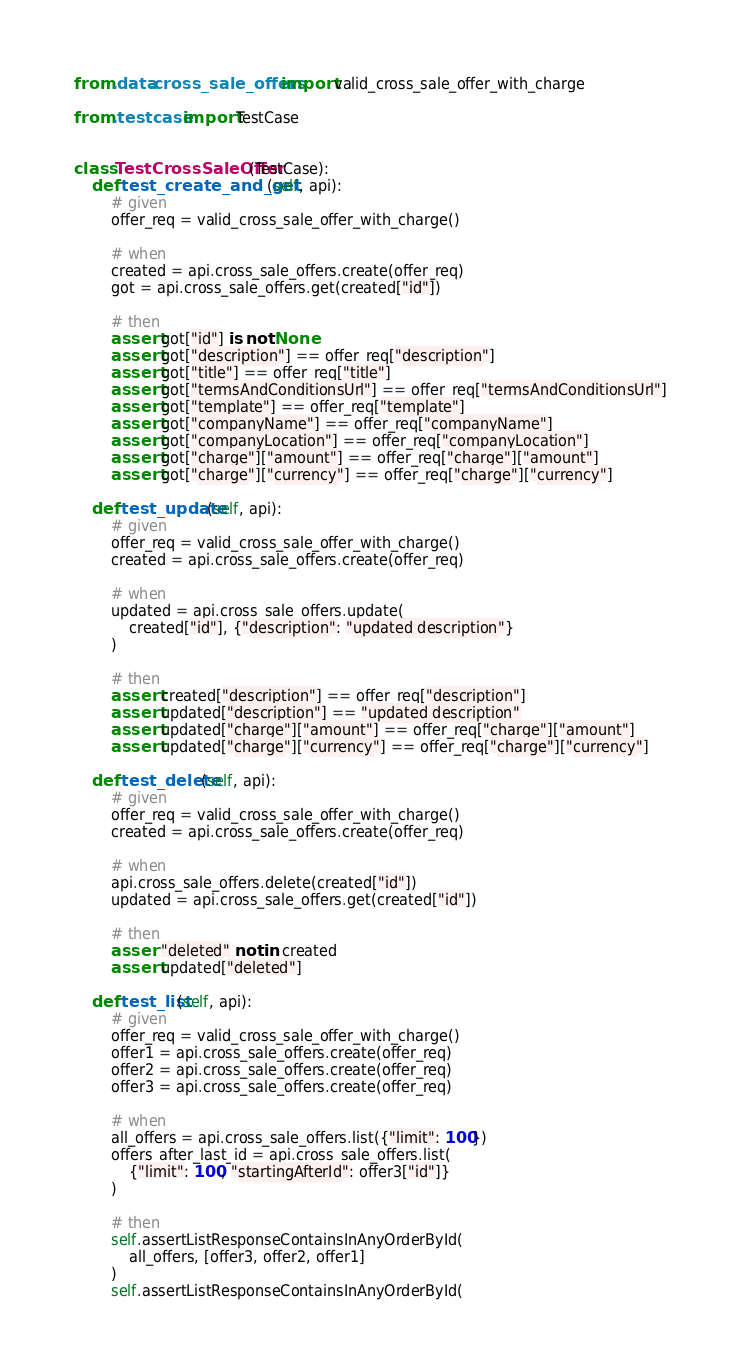<code> <loc_0><loc_0><loc_500><loc_500><_Python_>from .data.cross_sale_offers import valid_cross_sale_offer_with_charge

from .testcase import TestCase


class TestCrossSaleOffer(TestCase):
    def test_create_and_get(self, api):
        # given
        offer_req = valid_cross_sale_offer_with_charge()

        # when
        created = api.cross_sale_offers.create(offer_req)
        got = api.cross_sale_offers.get(created["id"])

        # then
        assert got["id"] is not None
        assert got["description"] == offer_req["description"]
        assert got["title"] == offer_req["title"]
        assert got["termsAndConditionsUrl"] == offer_req["termsAndConditionsUrl"]
        assert got["template"] == offer_req["template"]
        assert got["companyName"] == offer_req["companyName"]
        assert got["companyLocation"] == offer_req["companyLocation"]
        assert got["charge"]["amount"] == offer_req["charge"]["amount"]
        assert got["charge"]["currency"] == offer_req["charge"]["currency"]

    def test_update(self, api):
        # given
        offer_req = valid_cross_sale_offer_with_charge()
        created = api.cross_sale_offers.create(offer_req)

        # when
        updated = api.cross_sale_offers.update(
            created["id"], {"description": "updated description"}
        )

        # then
        assert created["description"] == offer_req["description"]
        assert updated["description"] == "updated description"
        assert updated["charge"]["amount"] == offer_req["charge"]["amount"]
        assert updated["charge"]["currency"] == offer_req["charge"]["currency"]

    def test_delete(self, api):
        # given
        offer_req = valid_cross_sale_offer_with_charge()
        created = api.cross_sale_offers.create(offer_req)

        # when
        api.cross_sale_offers.delete(created["id"])
        updated = api.cross_sale_offers.get(created["id"])

        # then
        assert "deleted" not in created
        assert updated["deleted"]

    def test_list(self, api):
        # given
        offer_req = valid_cross_sale_offer_with_charge()
        offer1 = api.cross_sale_offers.create(offer_req)
        offer2 = api.cross_sale_offers.create(offer_req)
        offer3 = api.cross_sale_offers.create(offer_req)

        # when
        all_offers = api.cross_sale_offers.list({"limit": 100})
        offers_after_last_id = api.cross_sale_offers.list(
            {"limit": 100, "startingAfterId": offer3["id"]}
        )

        # then
        self.assertListResponseContainsInAnyOrderById(
            all_offers, [offer3, offer2, offer1]
        )
        self.assertListResponseContainsInAnyOrderById(</code> 